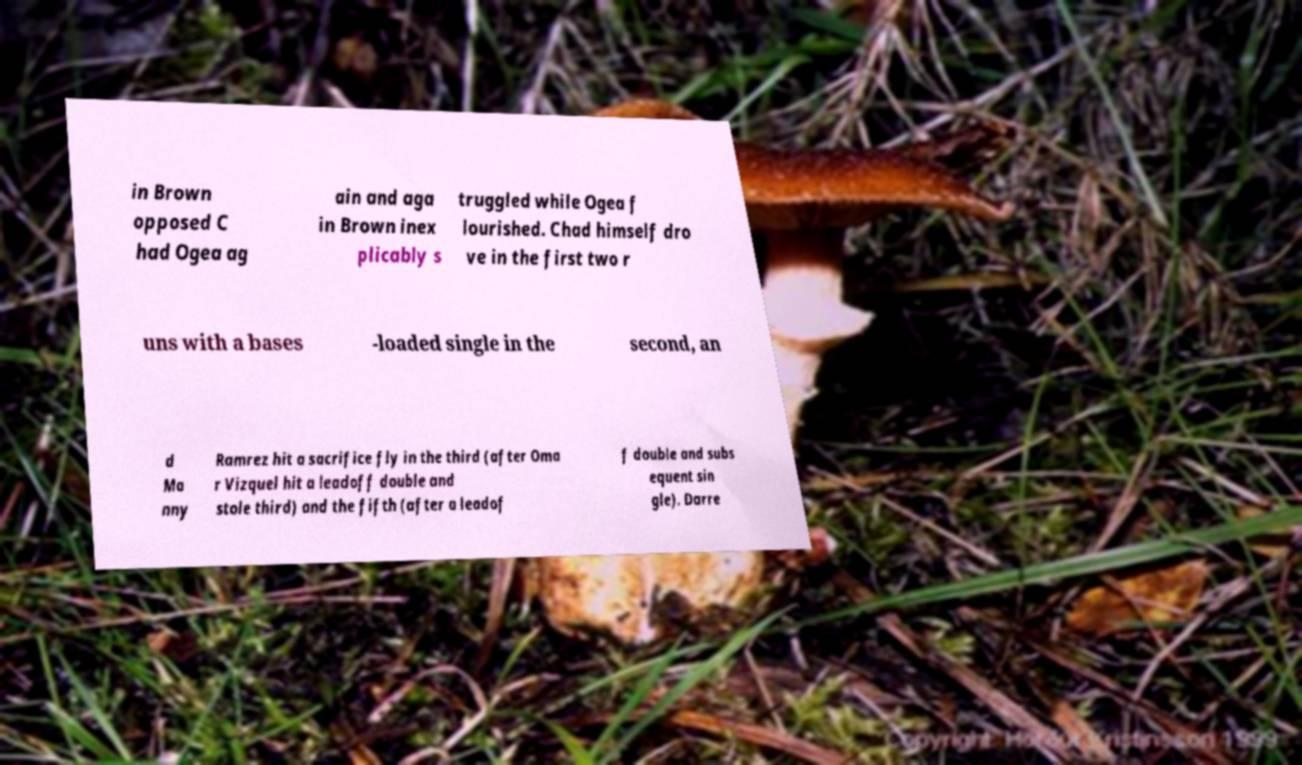Please read and relay the text visible in this image. What does it say? in Brown opposed C had Ogea ag ain and aga in Brown inex plicably s truggled while Ogea f lourished. Chad himself dro ve in the first two r uns with a bases -loaded single in the second, an d Ma nny Ramrez hit a sacrifice fly in the third (after Oma r Vizquel hit a leadoff double and stole third) and the fifth (after a leadof f double and subs equent sin gle). Darre 